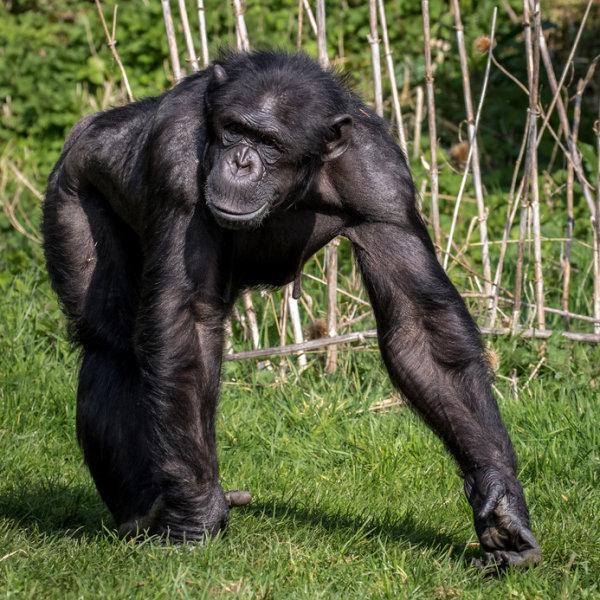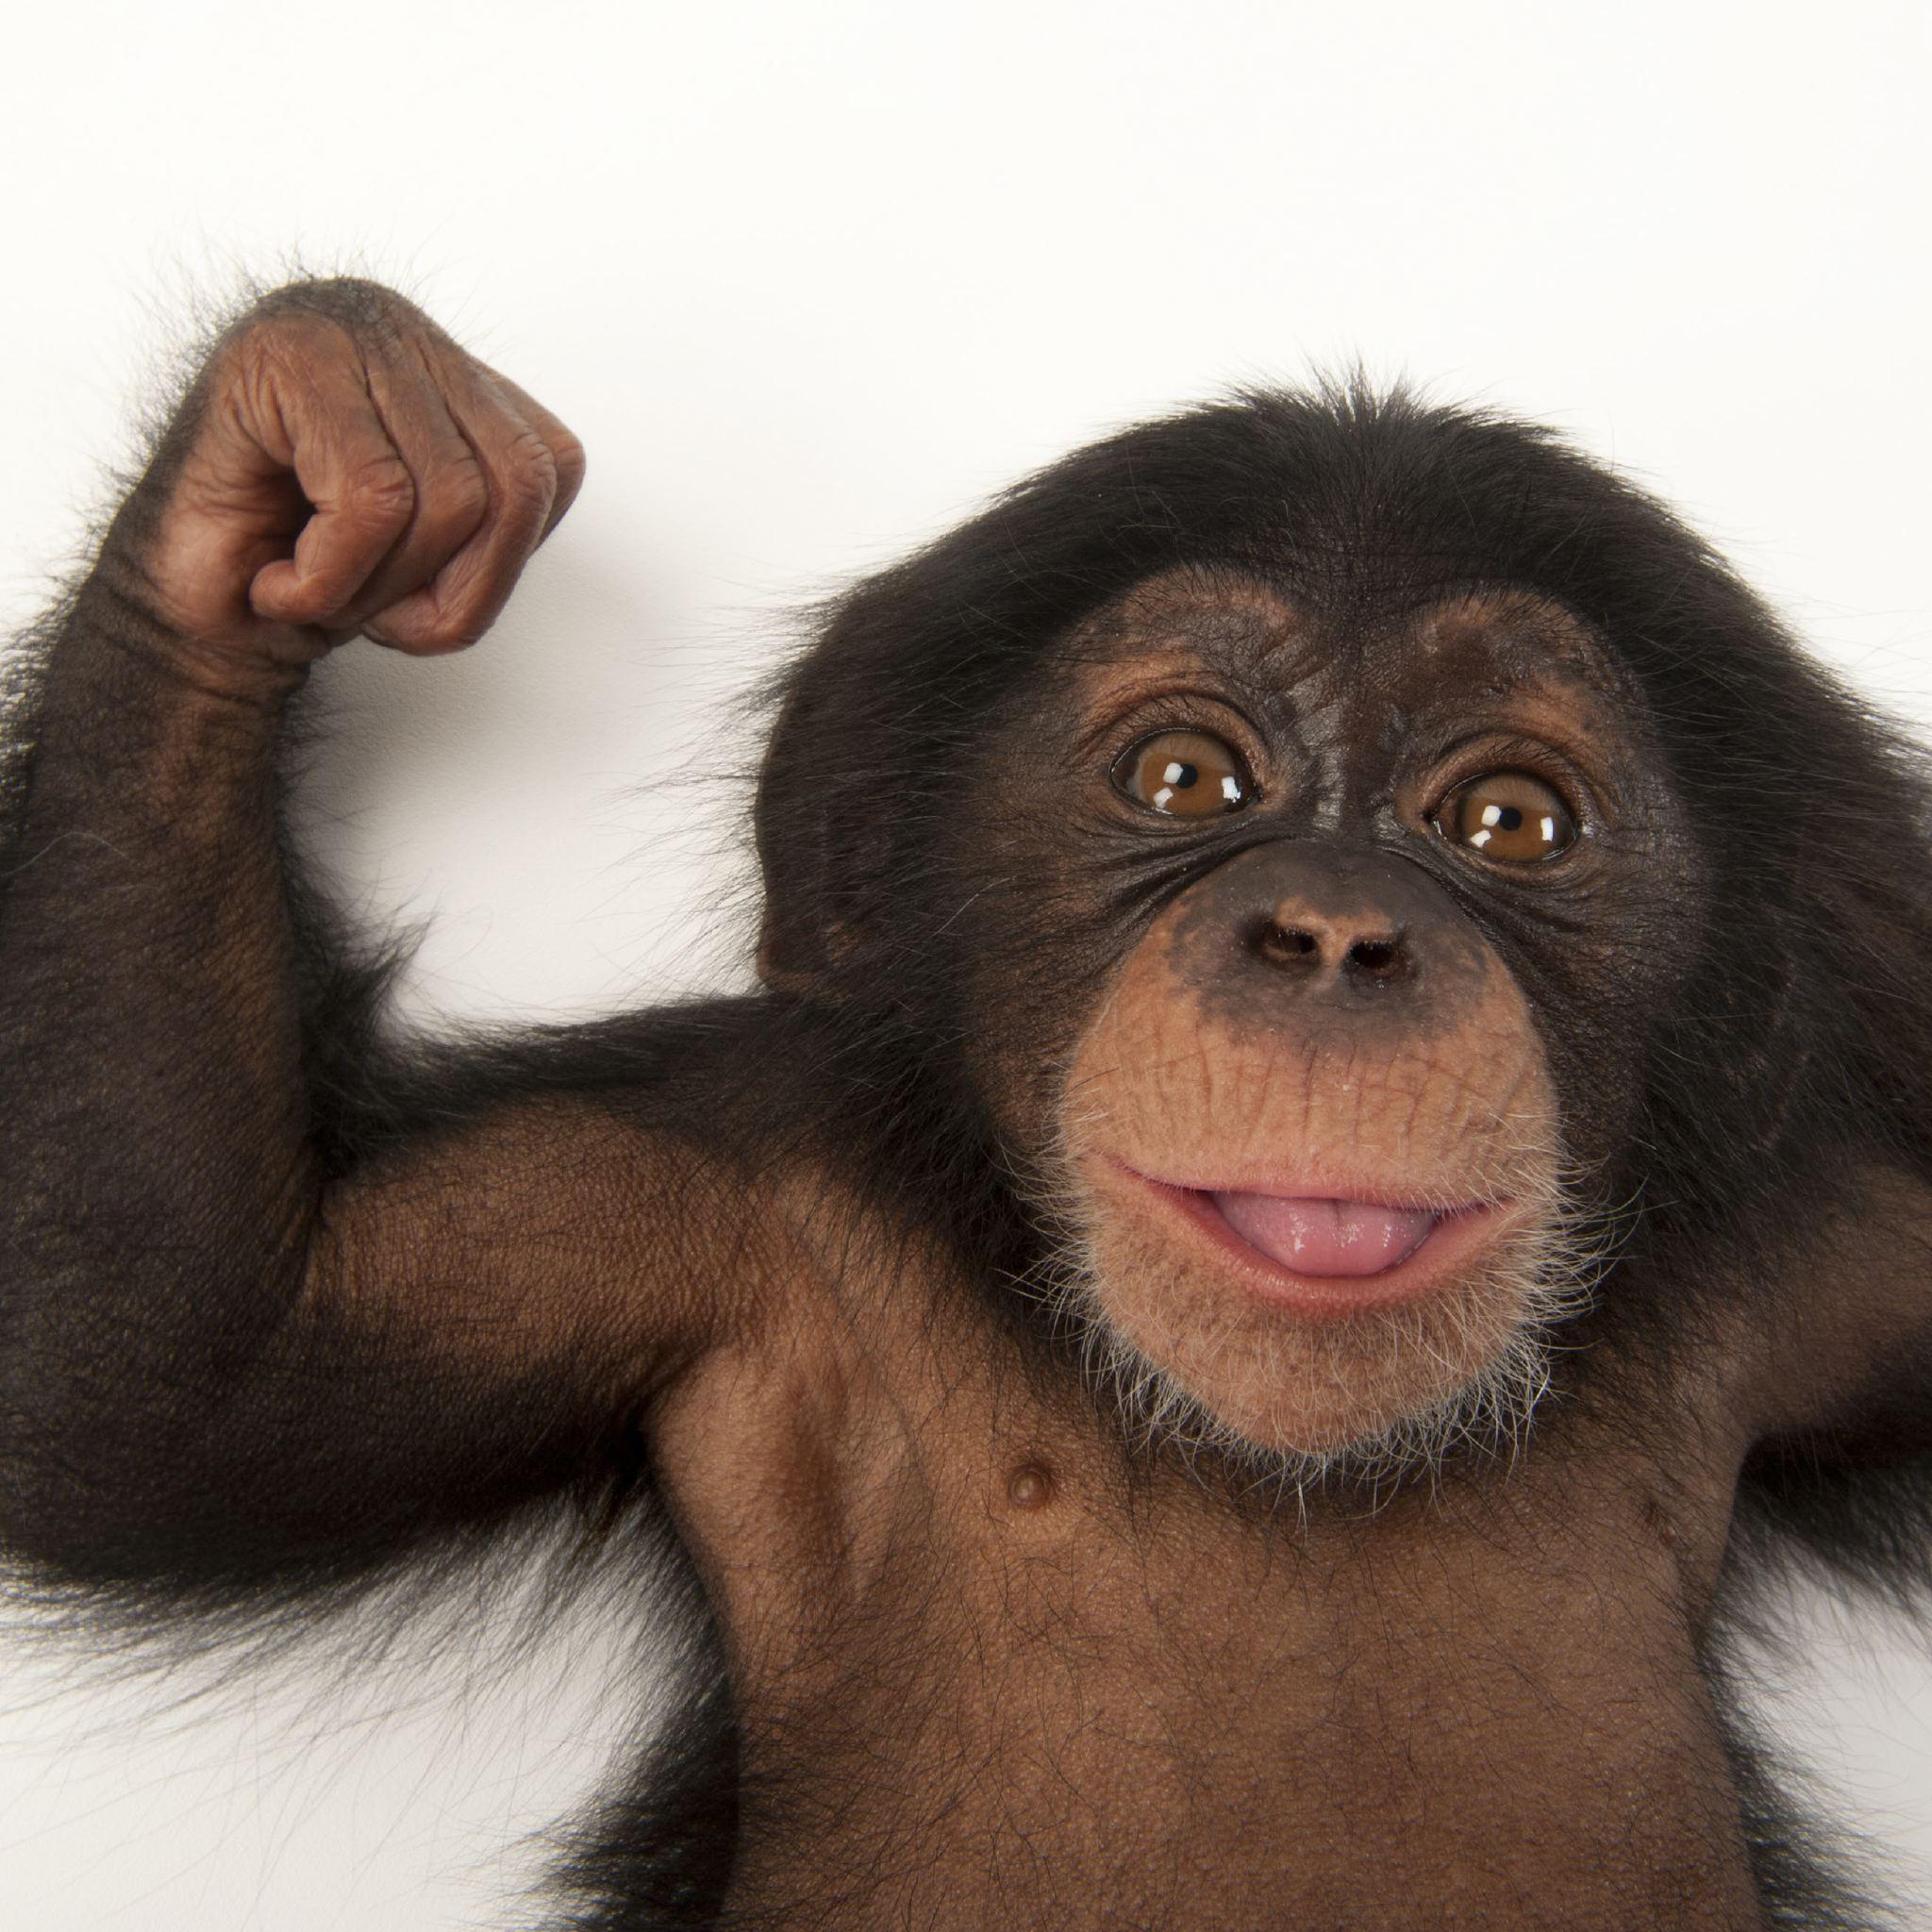The first image is the image on the left, the second image is the image on the right. Examine the images to the left and right. Is the description "At least one of the images shows more than one chimpanzee." accurate? Answer yes or no. No. 